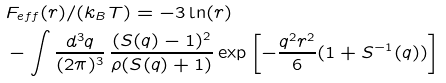<formula> <loc_0><loc_0><loc_500><loc_500>& F _ { e f f } ( r ) / ( k _ { B } T ) = - 3 \ln ( r ) \\ & - \int \frac { d ^ { 3 } q } { ( 2 \pi ) ^ { 3 } } \, \frac { ( S ( q ) - 1 ) ^ { 2 } } { \rho ( S ( q ) + 1 ) } \exp \left [ - \frac { q ^ { 2 } r ^ { 2 } } { 6 } ( 1 + S ^ { - 1 } ( q ) ) \right ]</formula> 